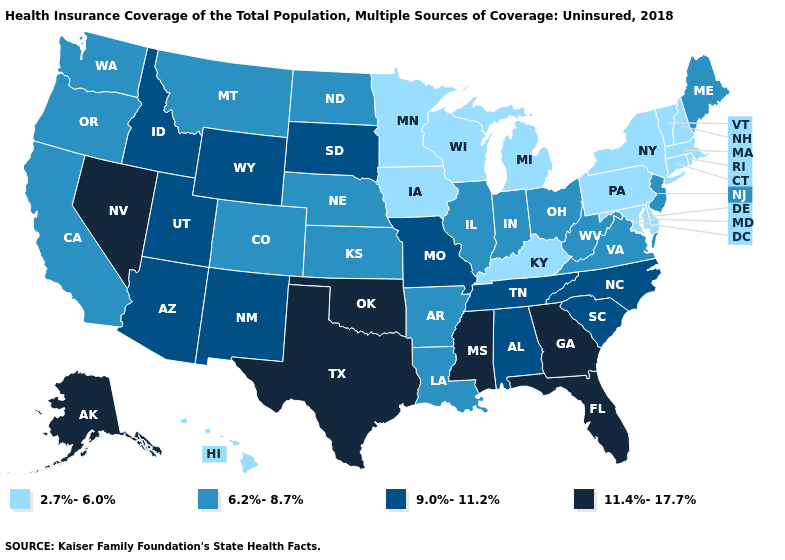Is the legend a continuous bar?
Write a very short answer. No. Does Nebraska have a lower value than South Dakota?
Answer briefly. Yes. Does the first symbol in the legend represent the smallest category?
Quick response, please. Yes. Among the states that border New York , does Massachusetts have the highest value?
Answer briefly. No. Among the states that border Massachusetts , which have the lowest value?
Short answer required. Connecticut, New Hampshire, New York, Rhode Island, Vermont. Which states have the lowest value in the MidWest?
Keep it brief. Iowa, Michigan, Minnesota, Wisconsin. What is the value of West Virginia?
Be succinct. 6.2%-8.7%. What is the lowest value in the MidWest?
Keep it brief. 2.7%-6.0%. Does Arkansas have the lowest value in the USA?
Quick response, please. No. Which states hav the highest value in the West?
Write a very short answer. Alaska, Nevada. What is the value of Connecticut?
Give a very brief answer. 2.7%-6.0%. What is the highest value in the USA?
Short answer required. 11.4%-17.7%. Among the states that border Rhode Island , which have the highest value?
Concise answer only. Connecticut, Massachusetts. Name the states that have a value in the range 11.4%-17.7%?
Be succinct. Alaska, Florida, Georgia, Mississippi, Nevada, Oklahoma, Texas. Does the map have missing data?
Keep it brief. No. 